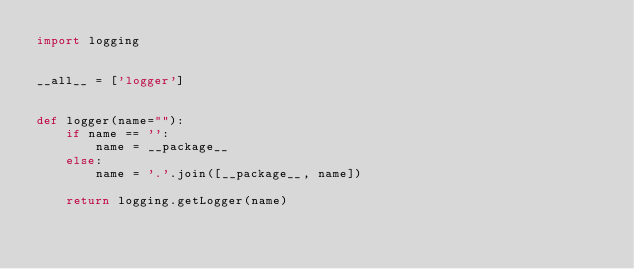<code> <loc_0><loc_0><loc_500><loc_500><_Python_>import logging


__all__ = ['logger']


def logger(name=""):
    if name == '':
        name = __package__
    else:
        name = '.'.join([__package__, name])

    return logging.getLogger(name)
</code> 